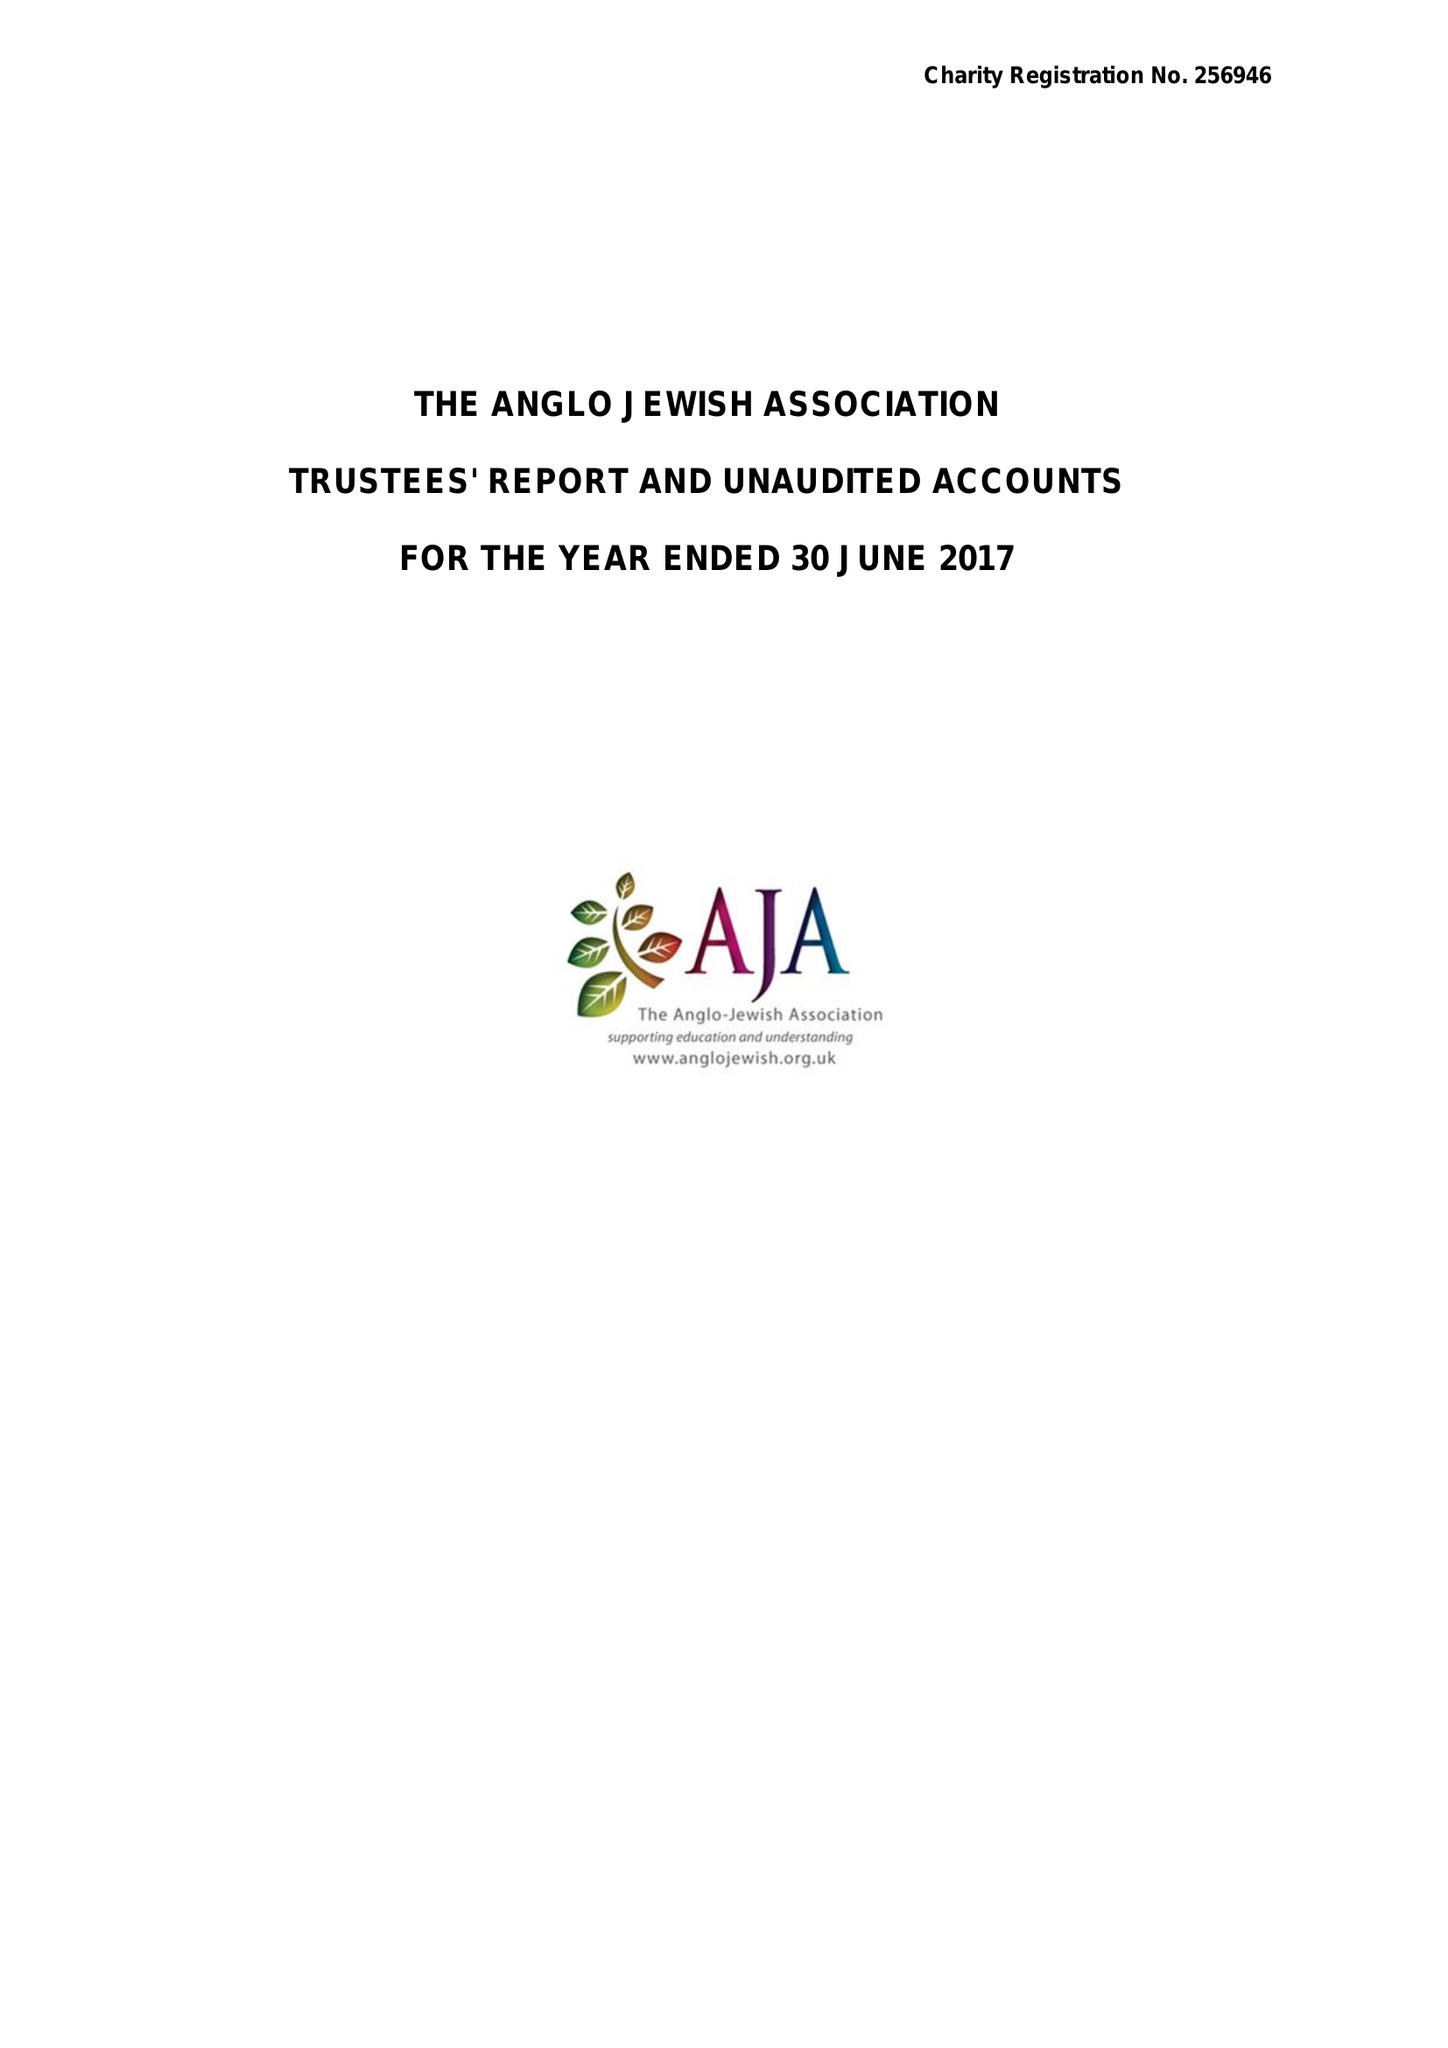What is the value for the charity_number?
Answer the question using a single word or phrase. 256946 